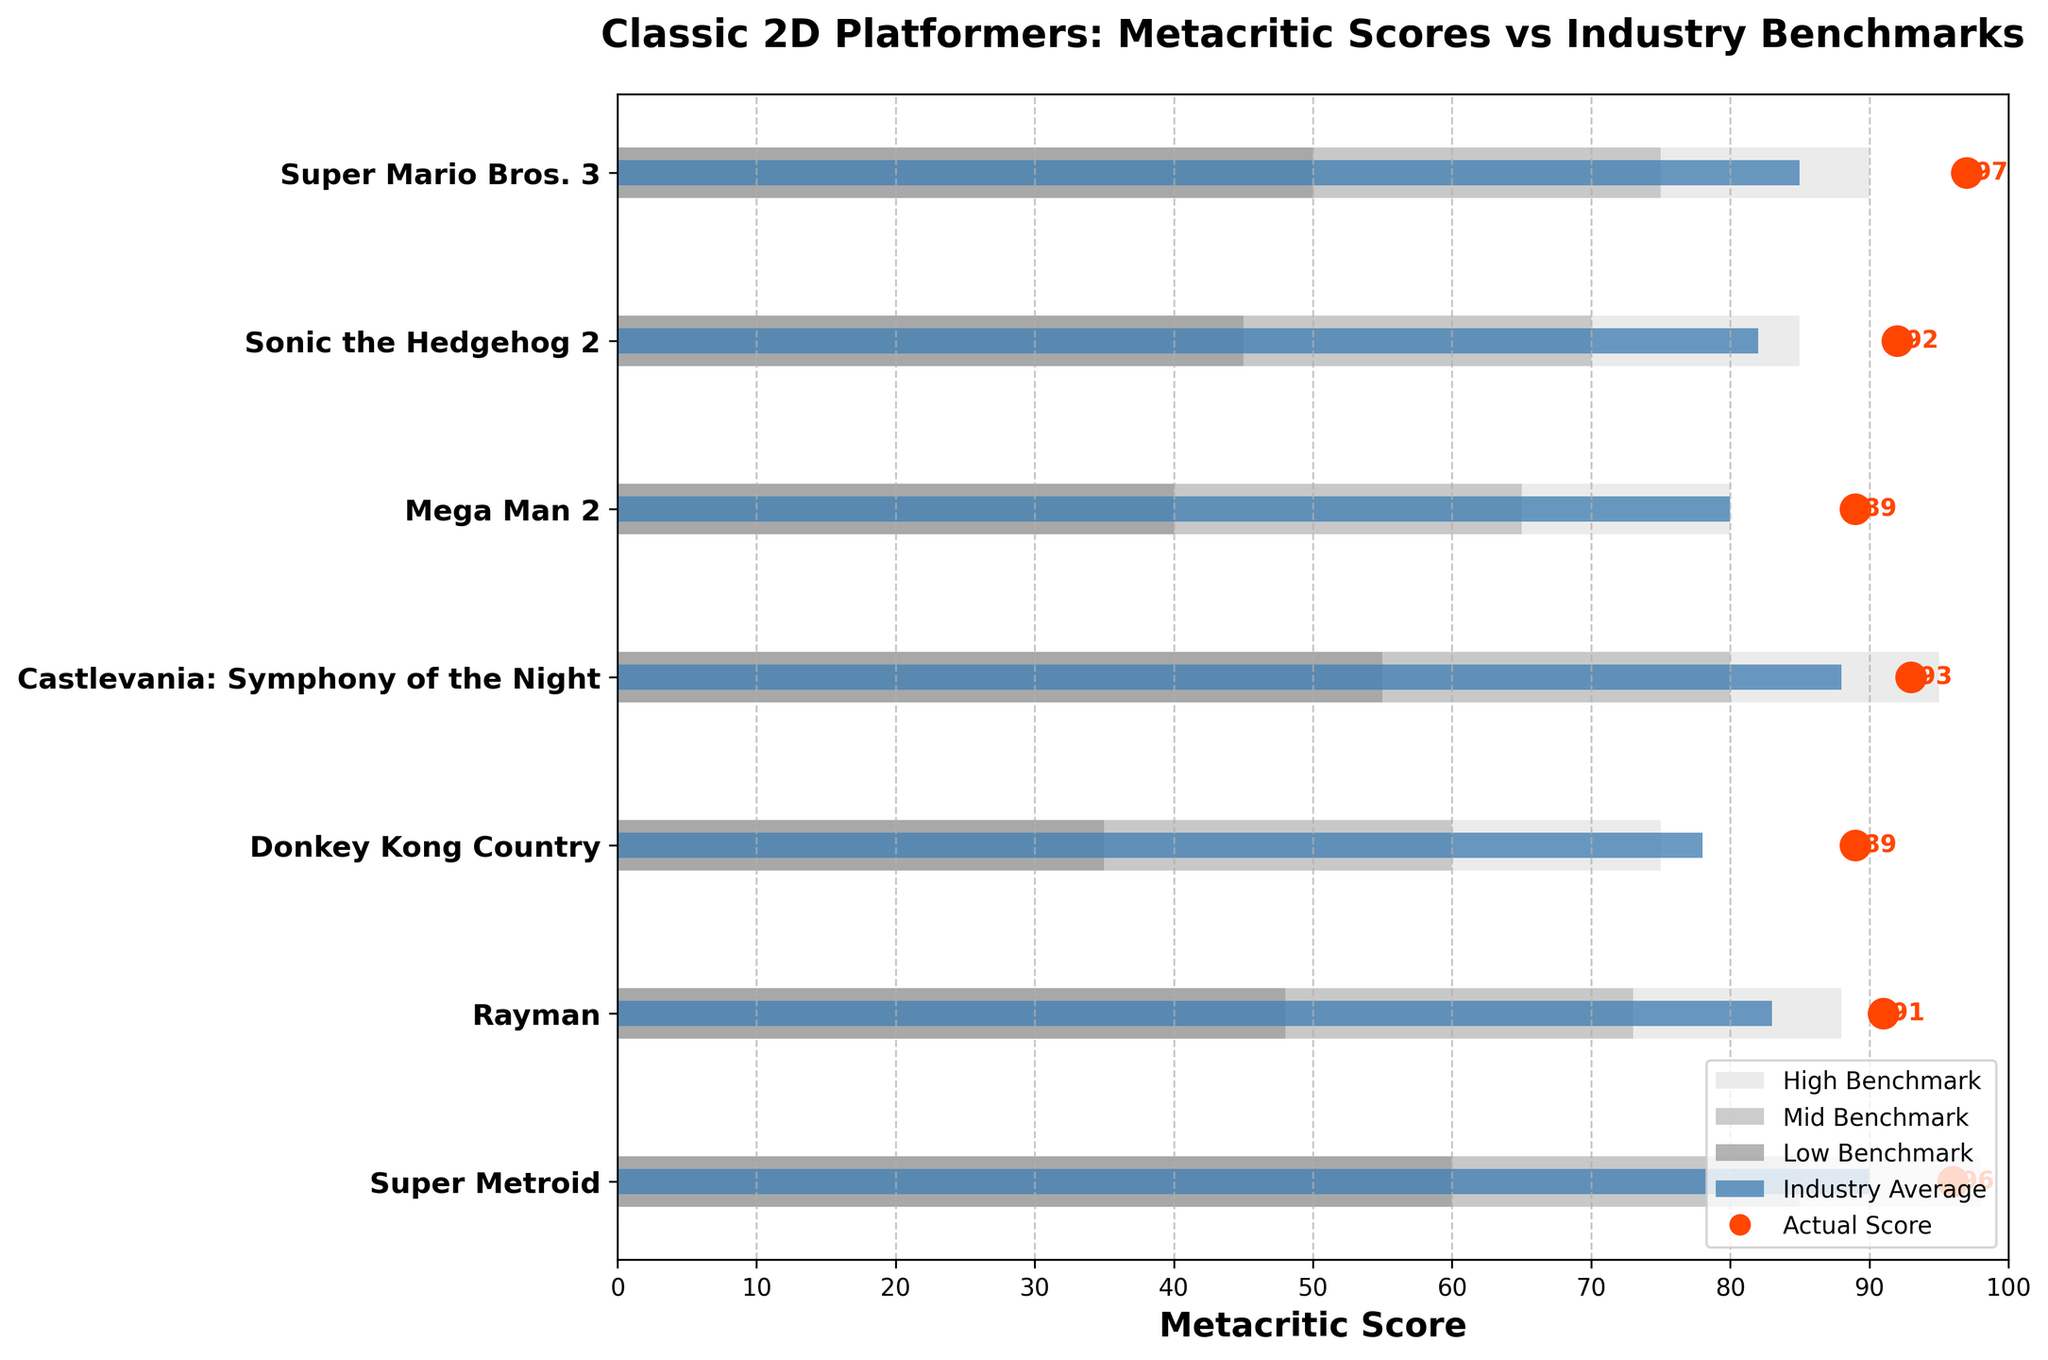How many games are displayed in the figure? Count the number of titles listed on the y-axis.
Answer: 7 What is the title of the figure? Read the main heading located above the chart.
Answer: Classic 2D Platformers: Metacritic Scores vs Industry Benchmarks Which game has the highest actual Metacritic score? Locate the game with the highest actual score indicated by the red dots.
Answer: Super Mario Bros. 3 Which game has the lowest industry average score? Identify the game with the smallest blue bar.
Answer: Donkey Kong Country What's the comparative score for Mega Man 2? Find Mega Man 2 on the y-axis and look at the length of the blue bar.
Answer: 80 Which game exceeds its highest benchmark range by the most points? Compare the actual scores (red dots) with the rightmost edge of the high benchmark (top gray bar) for each game to find the largest difference.
Answer: Super Mario Bros. 3 Is Super Metroid’s actual score higher than its industry average? Compare the length of the blue bar (industry average) with the position of the red dot (actual score) for Super Metroid.
Answer: Yes How many games scored equal to or above 90 in both actual and comparative scores? Check the red dots and blue bars for scores >= 90. Count the games that meet this criterion.
Answer: 2 (Super Metroid and Castlevania: Symphony of the Night) Which game has the widest range between its low and high benchmarks? Calculate the width of the low to high benchmark ranges for each game and determine the largest width.
Answer: Super Metroid What is the actual score of Rayman? Locate Rayman on the y-axis and identify the value of its corresponding red dot.
Answer: 91 